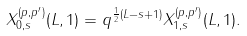Convert formula to latex. <formula><loc_0><loc_0><loc_500><loc_500>X _ { 0 , s } ^ { ( p , p ^ { \prime } ) } ( L , 1 ) = q ^ { \frac { 1 } { 2 } ( L - s + 1 ) } X _ { 1 , s } ^ { ( p , p ^ { \prime } ) } ( L , 1 ) .</formula> 